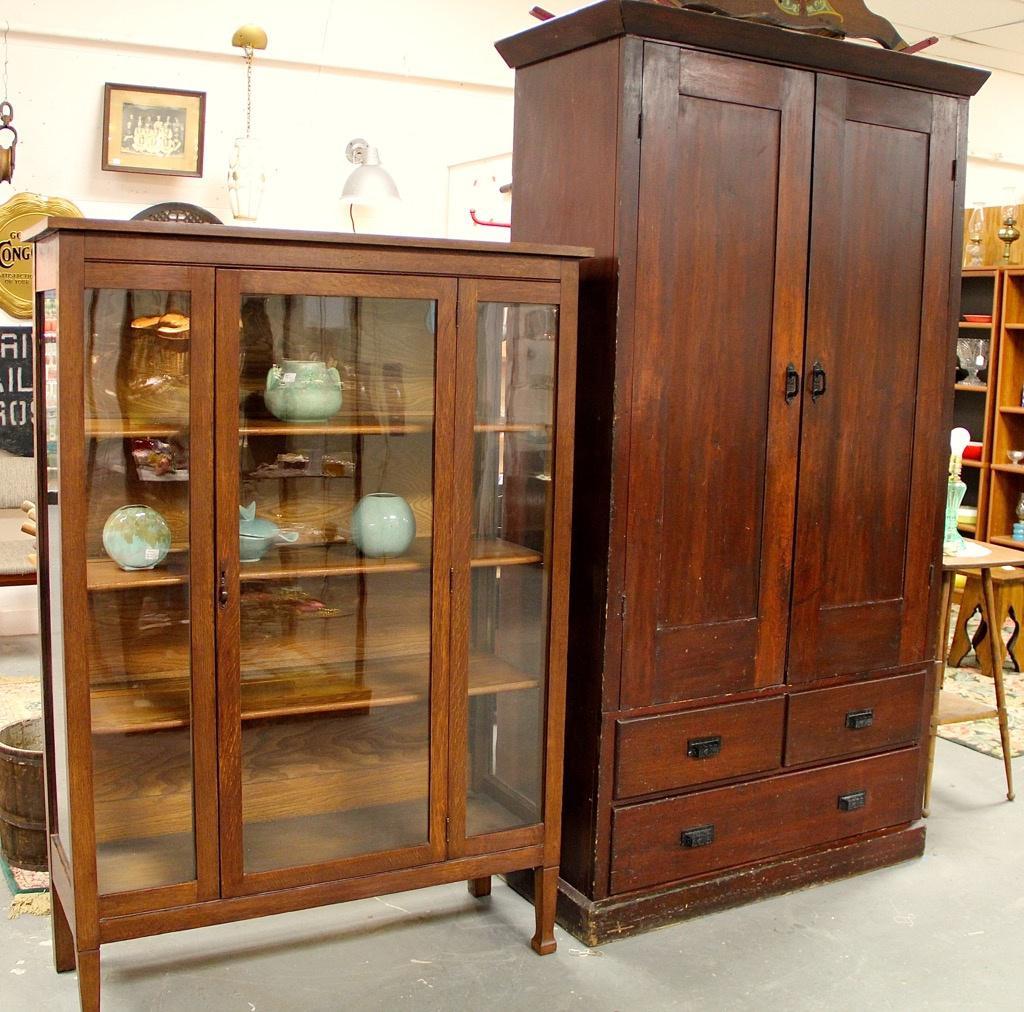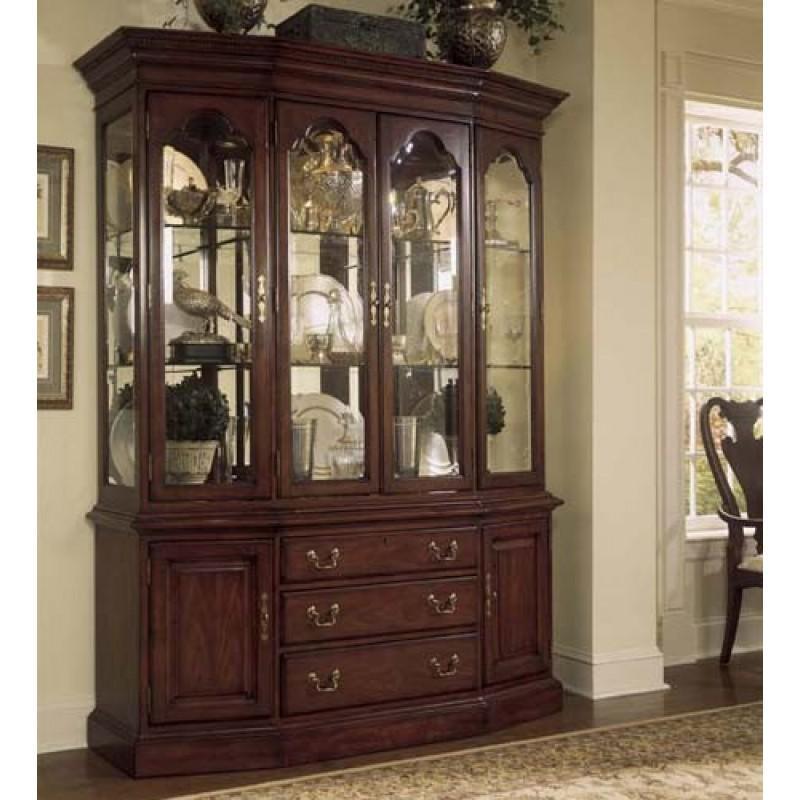The first image is the image on the left, the second image is the image on the right. Evaluate the accuracy of this statement regarding the images: "There are two cabinets in one of the images.". Is it true? Answer yes or no. Yes. 